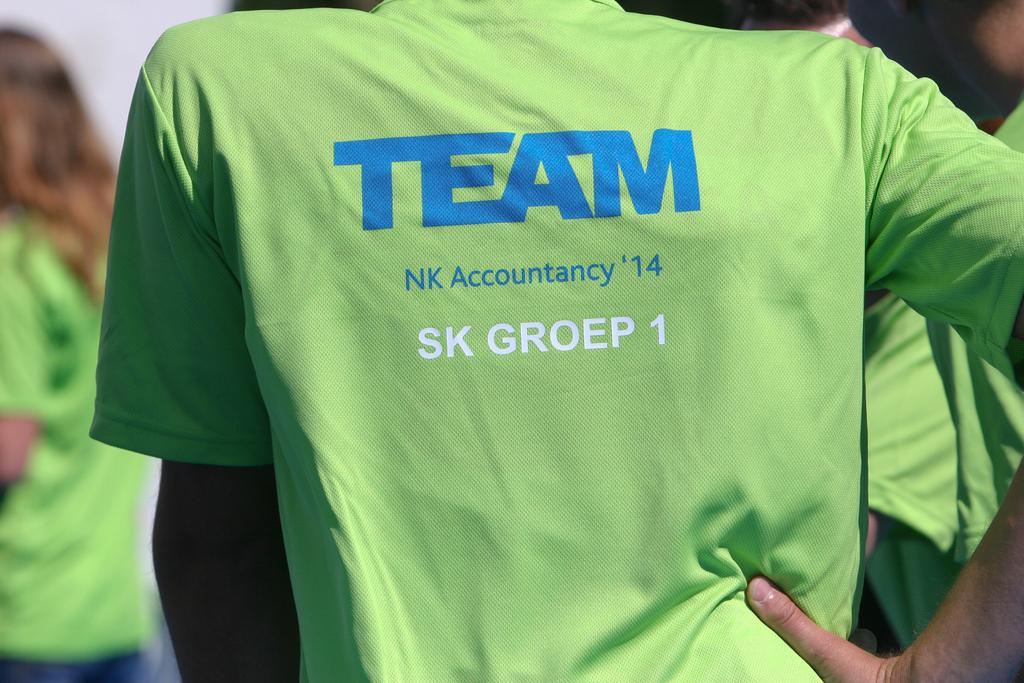<image>
Render a clear and concise summary of the photo. A green shirt with the word Team in blue is being worn. 